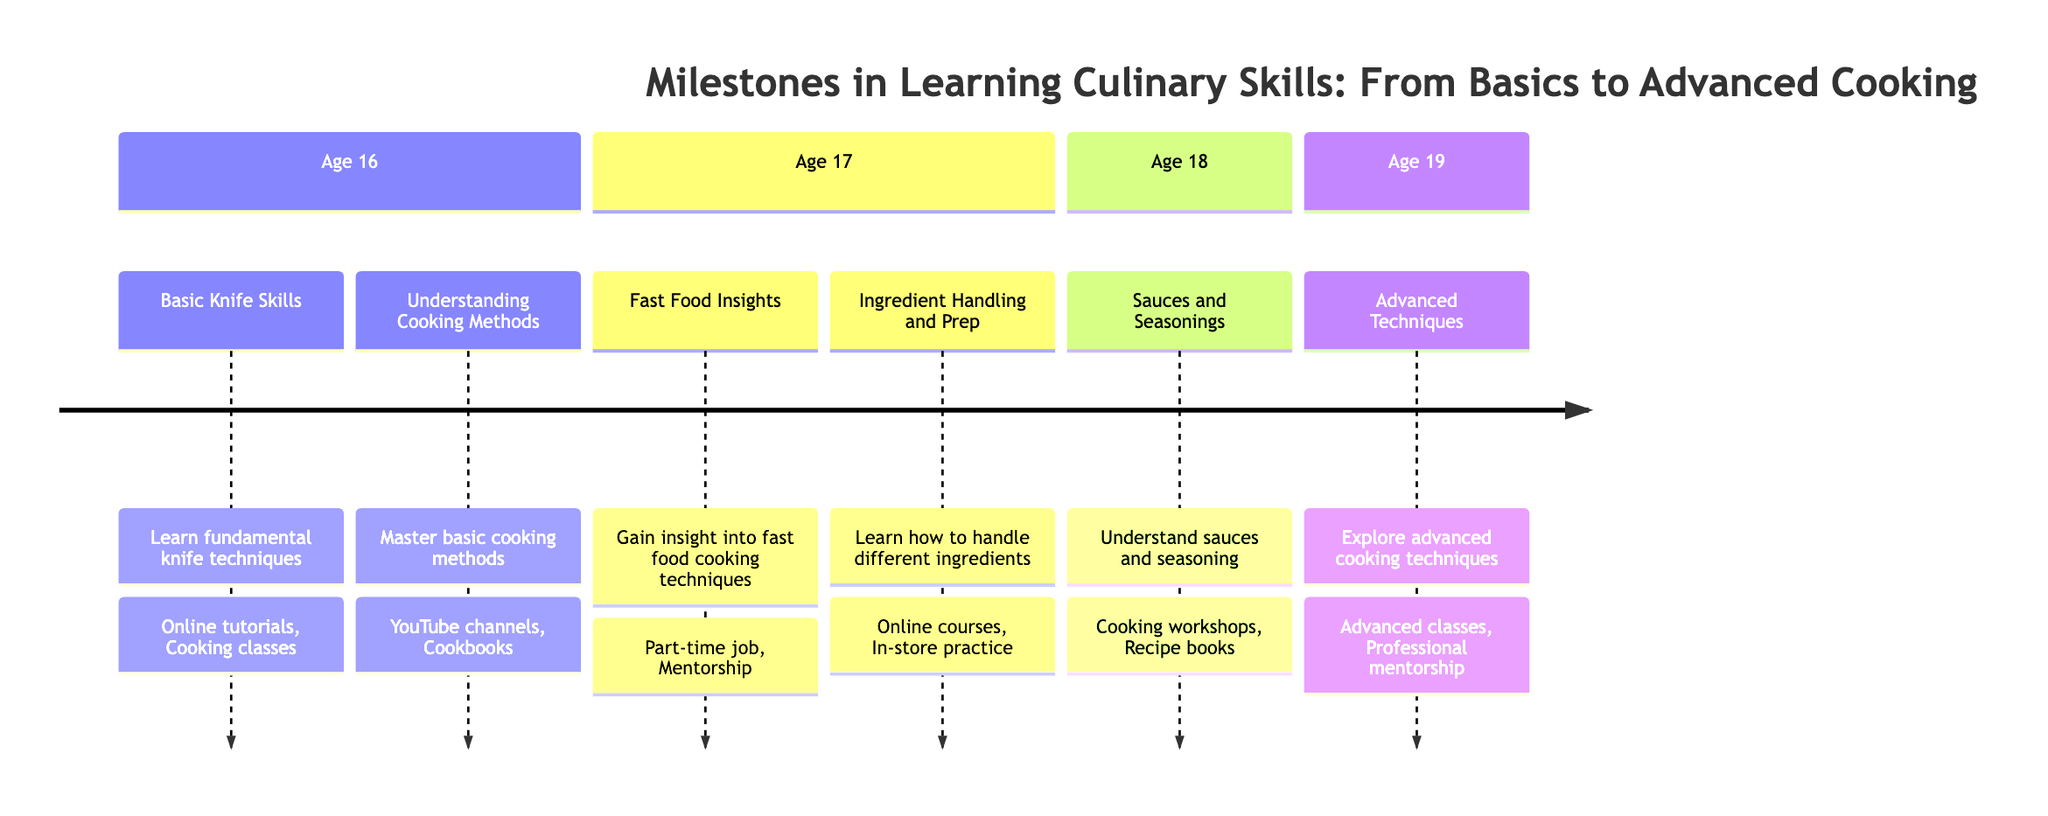What is the first milestone in learning culinary skills? The first milestone is listed under the age of 16 in the diagram, which is "Basic Knife Skills." This is the first entry in that section.
Answer: Basic Knife Skills At what age does "Sauces and Seasonings" occur? Upon reviewing the sections in the diagram, "Sauces and Seasonings" is found in the section for age 18, indicating the age at which this milestone occurs.
Answer: 18 How many total milestones are there in the timeline? By counting the individual milestones listed, there are six milestones in total, which can be verified by reviewing the entries.
Answer: 6 Which resources are listed for "Ingredient Handling and Prep"? The resources for this milestone can be found under the entry for "Ingredient Handling and Prep," specifically noting the two resources: "Online courses" and "In-store practice."
Answer: Online courses, In-store practice Identify the last milestone in the timeline. The last milestone can be seen in the section for age 19, which states "Advanced Techniques," marking it as the final entry in the diagram timeline.
Answer: Advanced Techniques What methodologies are mentioned for understanding cooking methods? The methodologies can be discovered by examining the "Understanding Cooking Methods" entry, which specifies the resources "YouTube channels" and "Cookbooks" for learning those methods.
Answer: YouTube channels, Cookbooks Which age is associated with "Fast Food Insights"? The entry for "Fast Food Insights" is located in the section for age 17 in the diagram, thus making that the associated age for this milestone.
Answer: 17 What cooking techniques are emphasized in "Fast Food Insights"? Evaluating the description of "Fast Food Insights," the emphasized techniques are "deep-frying," "grilling," and "assembling," which are detailed within the milestone.
Answer: Deep-frying, grilling, assembling Which milestone has the highest age associated with it? Checking the ages corresponding to each milestone, it becomes clear that "Advanced Techniques" is associated with age 19, the highest age in the timeline.
Answer: 19 